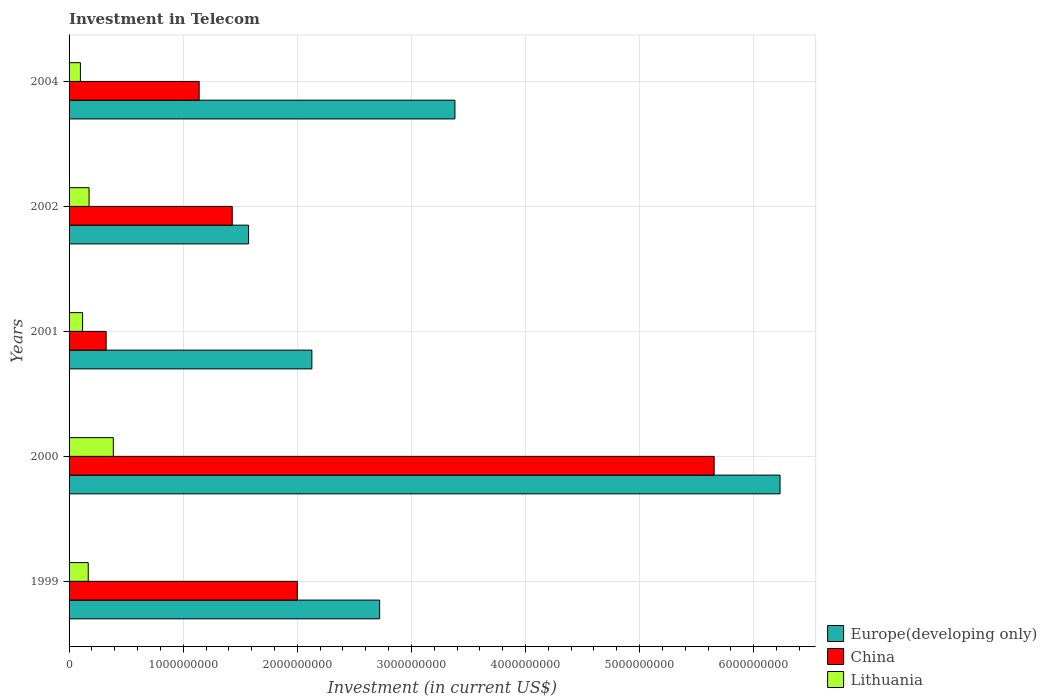Are the number of bars on each tick of the Y-axis equal?
Offer a terse response. Yes. How many bars are there on the 2nd tick from the top?
Offer a terse response. 3. What is the amount invested in telecom in China in 2000?
Your response must be concise. 5.65e+09. Across all years, what is the maximum amount invested in telecom in China?
Ensure brevity in your answer.  5.65e+09. Across all years, what is the minimum amount invested in telecom in China?
Keep it short and to the point. 3.25e+08. What is the total amount invested in telecom in China in the graph?
Your response must be concise. 1.05e+1. What is the difference between the amount invested in telecom in China in 1999 and that in 2002?
Offer a terse response. 5.70e+08. What is the difference between the amount invested in telecom in Europe(developing only) in 2001 and the amount invested in telecom in China in 2002?
Make the answer very short. 6.98e+08. What is the average amount invested in telecom in Lithuania per year?
Give a very brief answer. 1.90e+08. In the year 1999, what is the difference between the amount invested in telecom in Europe(developing only) and amount invested in telecom in China?
Provide a short and direct response. 7.22e+08. In how many years, is the amount invested in telecom in Europe(developing only) greater than 5400000000 US$?
Keep it short and to the point. 1. What is the ratio of the amount invested in telecom in China in 1999 to that in 2000?
Provide a short and direct response. 0.35. Is the amount invested in telecom in Europe(developing only) in 2000 less than that in 2002?
Your response must be concise. No. Is the difference between the amount invested in telecom in Europe(developing only) in 1999 and 2000 greater than the difference between the amount invested in telecom in China in 1999 and 2000?
Provide a succinct answer. Yes. What is the difference between the highest and the second highest amount invested in telecom in Europe(developing only)?
Offer a very short reply. 2.85e+09. What is the difference between the highest and the lowest amount invested in telecom in Lithuania?
Give a very brief answer. 2.88e+08. What does the 2nd bar from the top in 2001 represents?
Your answer should be compact. China. What does the 1st bar from the bottom in 2000 represents?
Provide a succinct answer. Europe(developing only). Is it the case that in every year, the sum of the amount invested in telecom in Lithuania and amount invested in telecom in Europe(developing only) is greater than the amount invested in telecom in China?
Your answer should be very brief. Yes. How many bars are there?
Provide a short and direct response. 15. How many years are there in the graph?
Give a very brief answer. 5. Are the values on the major ticks of X-axis written in scientific E-notation?
Provide a short and direct response. No. Does the graph contain any zero values?
Offer a very short reply. No. Does the graph contain grids?
Make the answer very short. Yes. Where does the legend appear in the graph?
Your answer should be compact. Bottom right. What is the title of the graph?
Offer a terse response. Investment in Telecom. What is the label or title of the X-axis?
Provide a short and direct response. Investment (in current US$). What is the Investment (in current US$) of Europe(developing only) in 1999?
Your answer should be compact. 2.72e+09. What is the Investment (in current US$) in China in 1999?
Provide a short and direct response. 2.00e+09. What is the Investment (in current US$) in Lithuania in 1999?
Keep it short and to the point. 1.68e+08. What is the Investment (in current US$) in Europe(developing only) in 2000?
Your response must be concise. 6.23e+09. What is the Investment (in current US$) in China in 2000?
Provide a short and direct response. 5.65e+09. What is the Investment (in current US$) of Lithuania in 2000?
Your response must be concise. 3.88e+08. What is the Investment (in current US$) of Europe(developing only) in 2001?
Give a very brief answer. 2.13e+09. What is the Investment (in current US$) in China in 2001?
Your response must be concise. 3.25e+08. What is the Investment (in current US$) in Lithuania in 2001?
Make the answer very short. 1.18e+08. What is the Investment (in current US$) of Europe(developing only) in 2002?
Ensure brevity in your answer.  1.57e+09. What is the Investment (in current US$) of China in 2002?
Your answer should be compact. 1.43e+09. What is the Investment (in current US$) in Lithuania in 2002?
Make the answer very short. 1.75e+08. What is the Investment (in current US$) of Europe(developing only) in 2004?
Ensure brevity in your answer.  3.38e+09. What is the Investment (in current US$) in China in 2004?
Keep it short and to the point. 1.14e+09. What is the Investment (in current US$) in Lithuania in 2004?
Your answer should be compact. 9.95e+07. Across all years, what is the maximum Investment (in current US$) in Europe(developing only)?
Provide a short and direct response. 6.23e+09. Across all years, what is the maximum Investment (in current US$) of China?
Provide a short and direct response. 5.65e+09. Across all years, what is the maximum Investment (in current US$) of Lithuania?
Offer a very short reply. 3.88e+08. Across all years, what is the minimum Investment (in current US$) of Europe(developing only)?
Keep it short and to the point. 1.57e+09. Across all years, what is the minimum Investment (in current US$) of China?
Your response must be concise. 3.25e+08. Across all years, what is the minimum Investment (in current US$) in Lithuania?
Provide a short and direct response. 9.95e+07. What is the total Investment (in current US$) in Europe(developing only) in the graph?
Give a very brief answer. 1.60e+1. What is the total Investment (in current US$) in China in the graph?
Make the answer very short. 1.05e+1. What is the total Investment (in current US$) in Lithuania in the graph?
Ensure brevity in your answer.  9.49e+08. What is the difference between the Investment (in current US$) in Europe(developing only) in 1999 and that in 2000?
Your answer should be very brief. -3.51e+09. What is the difference between the Investment (in current US$) of China in 1999 and that in 2000?
Make the answer very short. -3.65e+09. What is the difference between the Investment (in current US$) of Lithuania in 1999 and that in 2000?
Your answer should be very brief. -2.20e+08. What is the difference between the Investment (in current US$) in Europe(developing only) in 1999 and that in 2001?
Your response must be concise. 5.94e+08. What is the difference between the Investment (in current US$) in China in 1999 and that in 2001?
Offer a terse response. 1.68e+09. What is the difference between the Investment (in current US$) in Lithuania in 1999 and that in 2001?
Provide a short and direct response. 4.95e+07. What is the difference between the Investment (in current US$) of Europe(developing only) in 1999 and that in 2002?
Offer a terse response. 1.15e+09. What is the difference between the Investment (in current US$) in China in 1999 and that in 2002?
Your answer should be very brief. 5.70e+08. What is the difference between the Investment (in current US$) of Lithuania in 1999 and that in 2002?
Ensure brevity in your answer.  -7.30e+06. What is the difference between the Investment (in current US$) in Europe(developing only) in 1999 and that in 2004?
Ensure brevity in your answer.  -6.60e+08. What is the difference between the Investment (in current US$) of China in 1999 and that in 2004?
Give a very brief answer. 8.60e+08. What is the difference between the Investment (in current US$) in Lithuania in 1999 and that in 2004?
Provide a short and direct response. 6.85e+07. What is the difference between the Investment (in current US$) of Europe(developing only) in 2000 and that in 2001?
Your answer should be very brief. 4.10e+09. What is the difference between the Investment (in current US$) in China in 2000 and that in 2001?
Keep it short and to the point. 5.33e+09. What is the difference between the Investment (in current US$) in Lithuania in 2000 and that in 2001?
Make the answer very short. 2.69e+08. What is the difference between the Investment (in current US$) in Europe(developing only) in 2000 and that in 2002?
Provide a succinct answer. 4.66e+09. What is the difference between the Investment (in current US$) of China in 2000 and that in 2002?
Offer a very short reply. 4.22e+09. What is the difference between the Investment (in current US$) of Lithuania in 2000 and that in 2002?
Offer a terse response. 2.12e+08. What is the difference between the Investment (in current US$) in Europe(developing only) in 2000 and that in 2004?
Your answer should be compact. 2.85e+09. What is the difference between the Investment (in current US$) of China in 2000 and that in 2004?
Offer a terse response. 4.51e+09. What is the difference between the Investment (in current US$) in Lithuania in 2000 and that in 2004?
Ensure brevity in your answer.  2.88e+08. What is the difference between the Investment (in current US$) in Europe(developing only) in 2001 and that in 2002?
Your response must be concise. 5.55e+08. What is the difference between the Investment (in current US$) of China in 2001 and that in 2002?
Keep it short and to the point. -1.10e+09. What is the difference between the Investment (in current US$) in Lithuania in 2001 and that in 2002?
Offer a very short reply. -5.68e+07. What is the difference between the Investment (in current US$) in Europe(developing only) in 2001 and that in 2004?
Ensure brevity in your answer.  -1.25e+09. What is the difference between the Investment (in current US$) of China in 2001 and that in 2004?
Keep it short and to the point. -8.15e+08. What is the difference between the Investment (in current US$) of Lithuania in 2001 and that in 2004?
Ensure brevity in your answer.  1.90e+07. What is the difference between the Investment (in current US$) in Europe(developing only) in 2002 and that in 2004?
Your response must be concise. -1.81e+09. What is the difference between the Investment (in current US$) of China in 2002 and that in 2004?
Offer a terse response. 2.90e+08. What is the difference between the Investment (in current US$) in Lithuania in 2002 and that in 2004?
Keep it short and to the point. 7.58e+07. What is the difference between the Investment (in current US$) of Europe(developing only) in 1999 and the Investment (in current US$) of China in 2000?
Provide a succinct answer. -2.93e+09. What is the difference between the Investment (in current US$) in Europe(developing only) in 1999 and the Investment (in current US$) in Lithuania in 2000?
Keep it short and to the point. 2.33e+09. What is the difference between the Investment (in current US$) in China in 1999 and the Investment (in current US$) in Lithuania in 2000?
Offer a terse response. 1.61e+09. What is the difference between the Investment (in current US$) of Europe(developing only) in 1999 and the Investment (in current US$) of China in 2001?
Your answer should be compact. 2.40e+09. What is the difference between the Investment (in current US$) in Europe(developing only) in 1999 and the Investment (in current US$) in Lithuania in 2001?
Provide a short and direct response. 2.60e+09. What is the difference between the Investment (in current US$) of China in 1999 and the Investment (in current US$) of Lithuania in 2001?
Your answer should be compact. 1.88e+09. What is the difference between the Investment (in current US$) of Europe(developing only) in 1999 and the Investment (in current US$) of China in 2002?
Your answer should be compact. 1.29e+09. What is the difference between the Investment (in current US$) in Europe(developing only) in 1999 and the Investment (in current US$) in Lithuania in 2002?
Your answer should be very brief. 2.55e+09. What is the difference between the Investment (in current US$) of China in 1999 and the Investment (in current US$) of Lithuania in 2002?
Make the answer very short. 1.82e+09. What is the difference between the Investment (in current US$) of Europe(developing only) in 1999 and the Investment (in current US$) of China in 2004?
Offer a very short reply. 1.58e+09. What is the difference between the Investment (in current US$) of Europe(developing only) in 1999 and the Investment (in current US$) of Lithuania in 2004?
Your answer should be very brief. 2.62e+09. What is the difference between the Investment (in current US$) of China in 1999 and the Investment (in current US$) of Lithuania in 2004?
Offer a very short reply. 1.90e+09. What is the difference between the Investment (in current US$) in Europe(developing only) in 2000 and the Investment (in current US$) in China in 2001?
Offer a terse response. 5.91e+09. What is the difference between the Investment (in current US$) in Europe(developing only) in 2000 and the Investment (in current US$) in Lithuania in 2001?
Provide a short and direct response. 6.11e+09. What is the difference between the Investment (in current US$) in China in 2000 and the Investment (in current US$) in Lithuania in 2001?
Offer a terse response. 5.53e+09. What is the difference between the Investment (in current US$) in Europe(developing only) in 2000 and the Investment (in current US$) in China in 2002?
Your answer should be compact. 4.80e+09. What is the difference between the Investment (in current US$) in Europe(developing only) in 2000 and the Investment (in current US$) in Lithuania in 2002?
Keep it short and to the point. 6.06e+09. What is the difference between the Investment (in current US$) of China in 2000 and the Investment (in current US$) of Lithuania in 2002?
Your answer should be compact. 5.48e+09. What is the difference between the Investment (in current US$) of Europe(developing only) in 2000 and the Investment (in current US$) of China in 2004?
Your response must be concise. 5.09e+09. What is the difference between the Investment (in current US$) of Europe(developing only) in 2000 and the Investment (in current US$) of Lithuania in 2004?
Ensure brevity in your answer.  6.13e+09. What is the difference between the Investment (in current US$) of China in 2000 and the Investment (in current US$) of Lithuania in 2004?
Your answer should be very brief. 5.55e+09. What is the difference between the Investment (in current US$) of Europe(developing only) in 2001 and the Investment (in current US$) of China in 2002?
Provide a short and direct response. 6.98e+08. What is the difference between the Investment (in current US$) of Europe(developing only) in 2001 and the Investment (in current US$) of Lithuania in 2002?
Offer a very short reply. 1.95e+09. What is the difference between the Investment (in current US$) of China in 2001 and the Investment (in current US$) of Lithuania in 2002?
Provide a succinct answer. 1.50e+08. What is the difference between the Investment (in current US$) of Europe(developing only) in 2001 and the Investment (in current US$) of China in 2004?
Keep it short and to the point. 9.88e+08. What is the difference between the Investment (in current US$) of Europe(developing only) in 2001 and the Investment (in current US$) of Lithuania in 2004?
Offer a terse response. 2.03e+09. What is the difference between the Investment (in current US$) of China in 2001 and the Investment (in current US$) of Lithuania in 2004?
Your response must be concise. 2.26e+08. What is the difference between the Investment (in current US$) of Europe(developing only) in 2002 and the Investment (in current US$) of China in 2004?
Your answer should be very brief. 4.33e+08. What is the difference between the Investment (in current US$) of Europe(developing only) in 2002 and the Investment (in current US$) of Lithuania in 2004?
Provide a short and direct response. 1.47e+09. What is the difference between the Investment (in current US$) in China in 2002 and the Investment (in current US$) in Lithuania in 2004?
Offer a terse response. 1.33e+09. What is the average Investment (in current US$) in Europe(developing only) per year?
Offer a terse response. 3.21e+09. What is the average Investment (in current US$) of China per year?
Your answer should be very brief. 2.11e+09. What is the average Investment (in current US$) of Lithuania per year?
Make the answer very short. 1.90e+08. In the year 1999, what is the difference between the Investment (in current US$) of Europe(developing only) and Investment (in current US$) of China?
Your response must be concise. 7.22e+08. In the year 1999, what is the difference between the Investment (in current US$) in Europe(developing only) and Investment (in current US$) in Lithuania?
Ensure brevity in your answer.  2.55e+09. In the year 1999, what is the difference between the Investment (in current US$) of China and Investment (in current US$) of Lithuania?
Your response must be concise. 1.83e+09. In the year 2000, what is the difference between the Investment (in current US$) of Europe(developing only) and Investment (in current US$) of China?
Your answer should be very brief. 5.78e+08. In the year 2000, what is the difference between the Investment (in current US$) in Europe(developing only) and Investment (in current US$) in Lithuania?
Ensure brevity in your answer.  5.84e+09. In the year 2000, what is the difference between the Investment (in current US$) of China and Investment (in current US$) of Lithuania?
Provide a short and direct response. 5.27e+09. In the year 2001, what is the difference between the Investment (in current US$) of Europe(developing only) and Investment (in current US$) of China?
Keep it short and to the point. 1.80e+09. In the year 2001, what is the difference between the Investment (in current US$) in Europe(developing only) and Investment (in current US$) in Lithuania?
Your response must be concise. 2.01e+09. In the year 2001, what is the difference between the Investment (in current US$) in China and Investment (in current US$) in Lithuania?
Offer a very short reply. 2.06e+08. In the year 2002, what is the difference between the Investment (in current US$) of Europe(developing only) and Investment (in current US$) of China?
Provide a succinct answer. 1.43e+08. In the year 2002, what is the difference between the Investment (in current US$) in Europe(developing only) and Investment (in current US$) in Lithuania?
Offer a very short reply. 1.40e+09. In the year 2002, what is the difference between the Investment (in current US$) in China and Investment (in current US$) in Lithuania?
Your answer should be very brief. 1.25e+09. In the year 2004, what is the difference between the Investment (in current US$) of Europe(developing only) and Investment (in current US$) of China?
Offer a very short reply. 2.24e+09. In the year 2004, what is the difference between the Investment (in current US$) in Europe(developing only) and Investment (in current US$) in Lithuania?
Your answer should be very brief. 3.28e+09. In the year 2004, what is the difference between the Investment (in current US$) of China and Investment (in current US$) of Lithuania?
Your response must be concise. 1.04e+09. What is the ratio of the Investment (in current US$) in Europe(developing only) in 1999 to that in 2000?
Give a very brief answer. 0.44. What is the ratio of the Investment (in current US$) of China in 1999 to that in 2000?
Give a very brief answer. 0.35. What is the ratio of the Investment (in current US$) in Lithuania in 1999 to that in 2000?
Offer a very short reply. 0.43. What is the ratio of the Investment (in current US$) of Europe(developing only) in 1999 to that in 2001?
Offer a very short reply. 1.28. What is the ratio of the Investment (in current US$) in China in 1999 to that in 2001?
Your response must be concise. 6.15. What is the ratio of the Investment (in current US$) in Lithuania in 1999 to that in 2001?
Provide a succinct answer. 1.42. What is the ratio of the Investment (in current US$) of Europe(developing only) in 1999 to that in 2002?
Your answer should be compact. 1.73. What is the ratio of the Investment (in current US$) of China in 1999 to that in 2002?
Your response must be concise. 1.4. What is the ratio of the Investment (in current US$) in Lithuania in 1999 to that in 2002?
Your answer should be compact. 0.96. What is the ratio of the Investment (in current US$) in Europe(developing only) in 1999 to that in 2004?
Offer a terse response. 0.8. What is the ratio of the Investment (in current US$) in China in 1999 to that in 2004?
Give a very brief answer. 1.75. What is the ratio of the Investment (in current US$) of Lithuania in 1999 to that in 2004?
Provide a succinct answer. 1.69. What is the ratio of the Investment (in current US$) in Europe(developing only) in 2000 to that in 2001?
Provide a succinct answer. 2.93. What is the ratio of the Investment (in current US$) of China in 2000 to that in 2001?
Ensure brevity in your answer.  17.39. What is the ratio of the Investment (in current US$) of Lithuania in 2000 to that in 2001?
Make the answer very short. 3.27. What is the ratio of the Investment (in current US$) of Europe(developing only) in 2000 to that in 2002?
Ensure brevity in your answer.  3.96. What is the ratio of the Investment (in current US$) of China in 2000 to that in 2002?
Your answer should be compact. 3.95. What is the ratio of the Investment (in current US$) in Lithuania in 2000 to that in 2002?
Ensure brevity in your answer.  2.21. What is the ratio of the Investment (in current US$) in Europe(developing only) in 2000 to that in 2004?
Offer a very short reply. 1.84. What is the ratio of the Investment (in current US$) of China in 2000 to that in 2004?
Make the answer very short. 4.96. What is the ratio of the Investment (in current US$) in Lithuania in 2000 to that in 2004?
Your response must be concise. 3.9. What is the ratio of the Investment (in current US$) in Europe(developing only) in 2001 to that in 2002?
Offer a terse response. 1.35. What is the ratio of the Investment (in current US$) of China in 2001 to that in 2002?
Make the answer very short. 0.23. What is the ratio of the Investment (in current US$) of Lithuania in 2001 to that in 2002?
Offer a very short reply. 0.68. What is the ratio of the Investment (in current US$) of Europe(developing only) in 2001 to that in 2004?
Your answer should be very brief. 0.63. What is the ratio of the Investment (in current US$) in China in 2001 to that in 2004?
Offer a very short reply. 0.29. What is the ratio of the Investment (in current US$) in Lithuania in 2001 to that in 2004?
Make the answer very short. 1.19. What is the ratio of the Investment (in current US$) of Europe(developing only) in 2002 to that in 2004?
Your answer should be very brief. 0.47. What is the ratio of the Investment (in current US$) of China in 2002 to that in 2004?
Keep it short and to the point. 1.25. What is the ratio of the Investment (in current US$) of Lithuania in 2002 to that in 2004?
Give a very brief answer. 1.76. What is the difference between the highest and the second highest Investment (in current US$) of Europe(developing only)?
Make the answer very short. 2.85e+09. What is the difference between the highest and the second highest Investment (in current US$) of China?
Make the answer very short. 3.65e+09. What is the difference between the highest and the second highest Investment (in current US$) of Lithuania?
Offer a terse response. 2.12e+08. What is the difference between the highest and the lowest Investment (in current US$) in Europe(developing only)?
Give a very brief answer. 4.66e+09. What is the difference between the highest and the lowest Investment (in current US$) of China?
Give a very brief answer. 5.33e+09. What is the difference between the highest and the lowest Investment (in current US$) in Lithuania?
Offer a very short reply. 2.88e+08. 